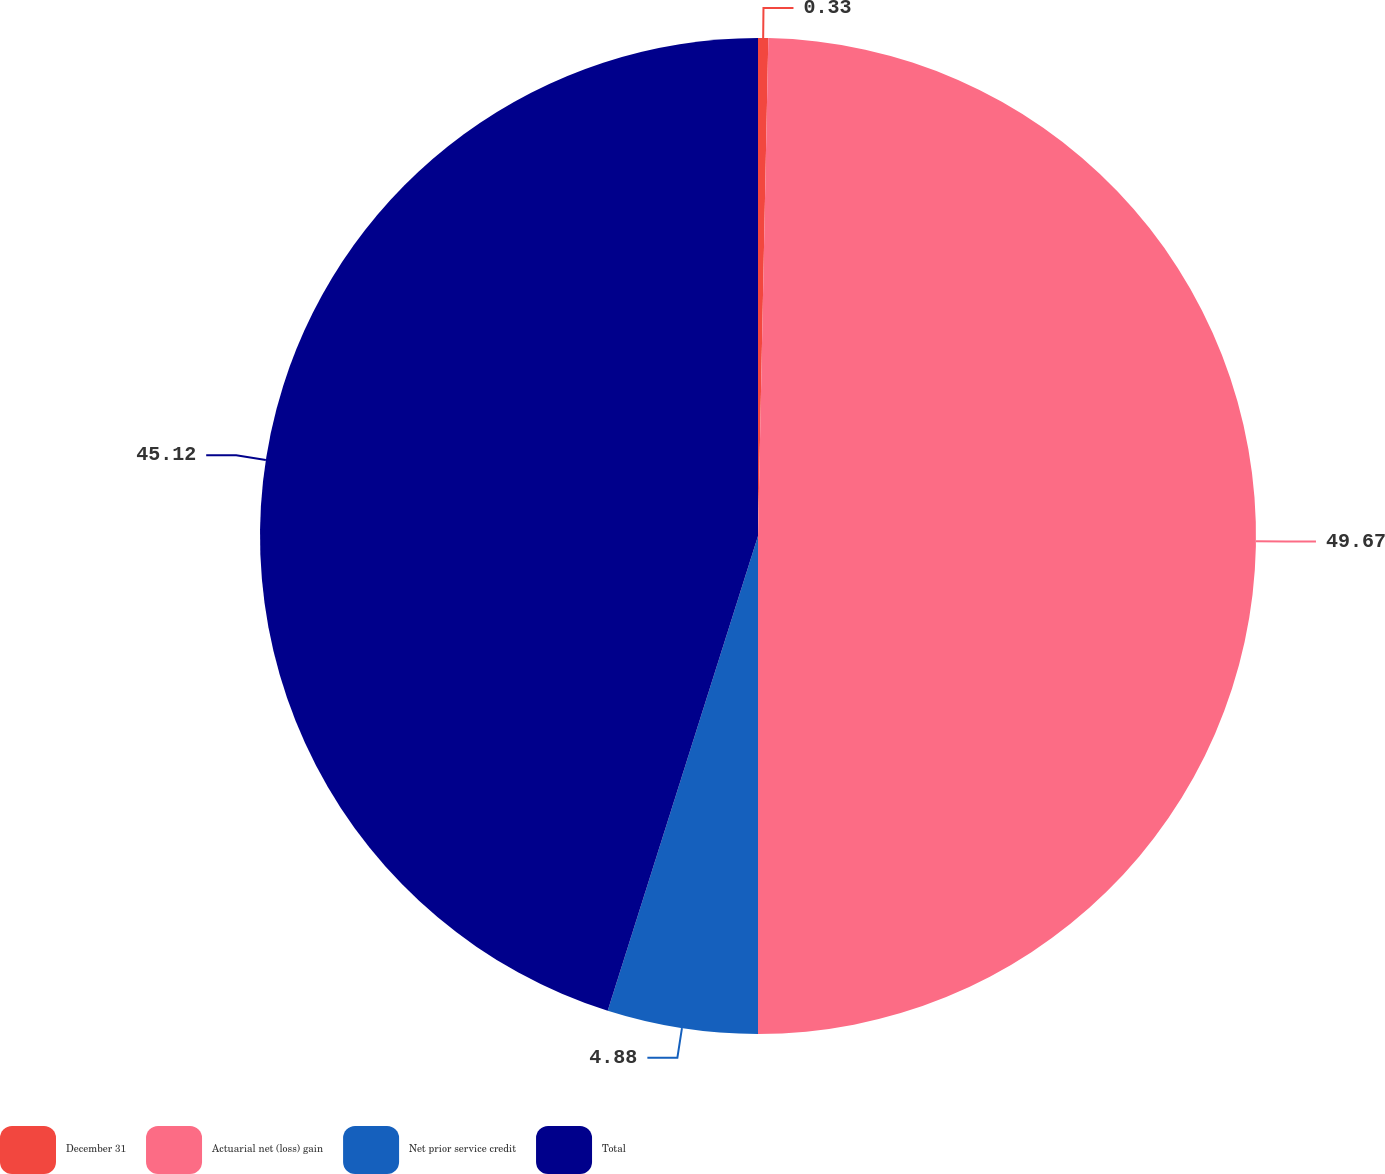Convert chart. <chart><loc_0><loc_0><loc_500><loc_500><pie_chart><fcel>December 31<fcel>Actuarial net (loss) gain<fcel>Net prior service credit<fcel>Total<nl><fcel>0.33%<fcel>49.67%<fcel>4.88%<fcel>45.12%<nl></chart> 